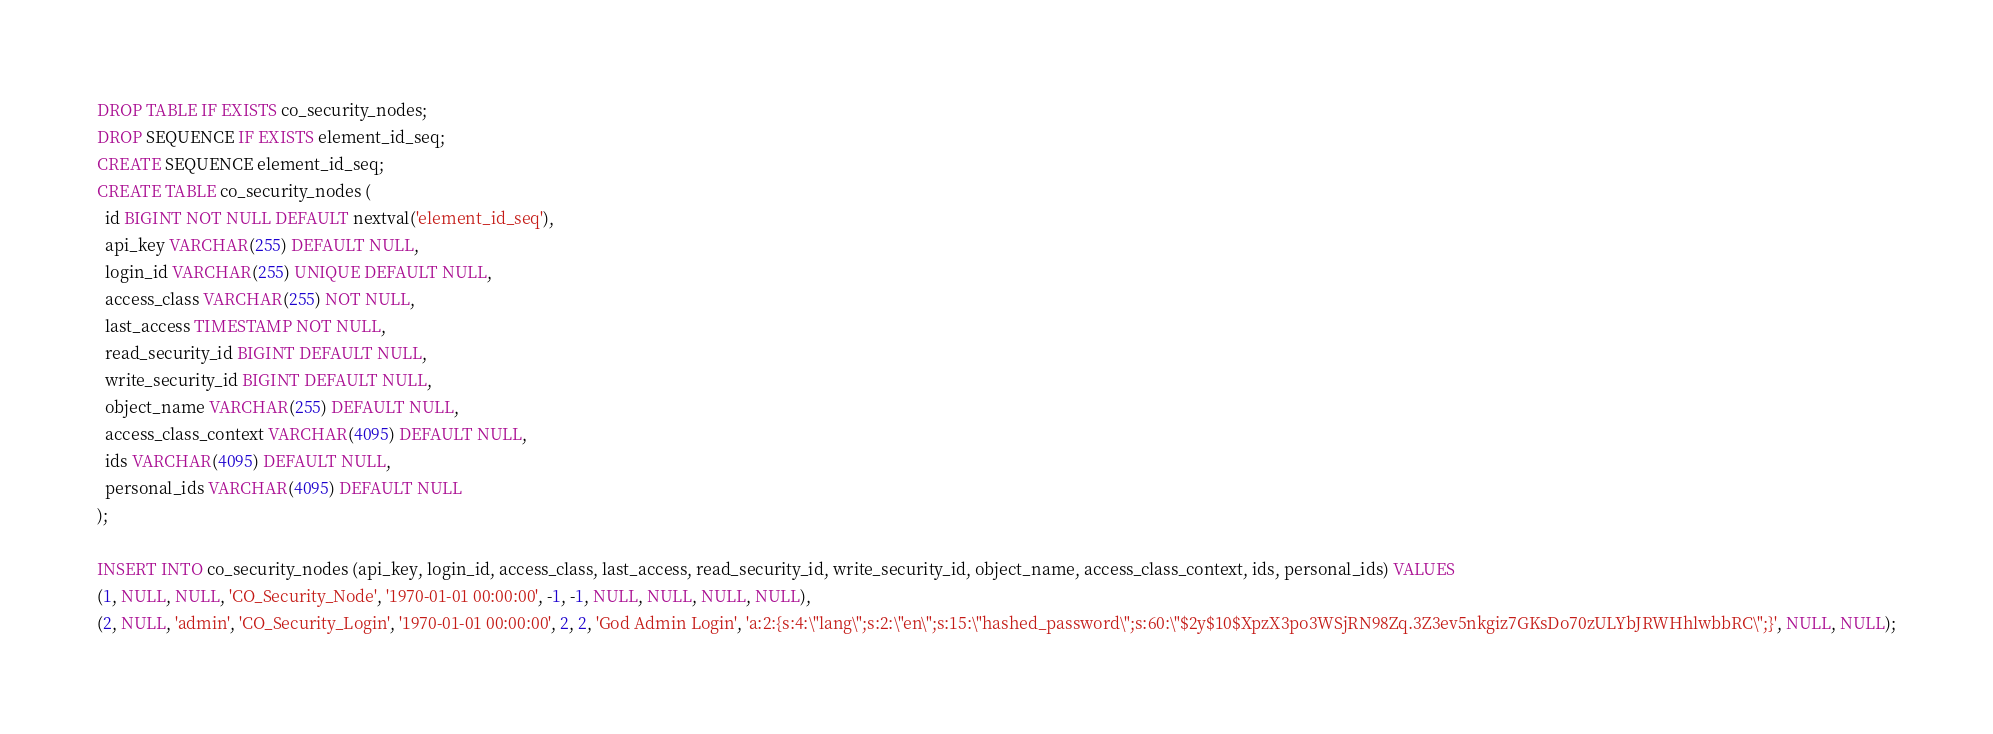Convert code to text. <code><loc_0><loc_0><loc_500><loc_500><_SQL_>DROP TABLE IF EXISTS co_security_nodes;
DROP SEQUENCE IF EXISTS element_id_seq;
CREATE SEQUENCE element_id_seq;
CREATE TABLE co_security_nodes (
  id BIGINT NOT NULL DEFAULT nextval('element_id_seq'),
  api_key VARCHAR(255) DEFAULT NULL,
  login_id VARCHAR(255) UNIQUE DEFAULT NULL,
  access_class VARCHAR(255) NOT NULL,
  last_access TIMESTAMP NOT NULL,
  read_security_id BIGINT DEFAULT NULL,
  write_security_id BIGINT DEFAULT NULL,
  object_name VARCHAR(255) DEFAULT NULL,
  access_class_context VARCHAR(4095) DEFAULT NULL,
  ids VARCHAR(4095) DEFAULT NULL,
  personal_ids VARCHAR(4095) DEFAULT NULL
);

INSERT INTO co_security_nodes (api_key, login_id, access_class, last_access, read_security_id, write_security_id, object_name, access_class_context, ids, personal_ids) VALUES
(1, NULL, NULL, 'CO_Security_Node', '1970-01-01 00:00:00', -1, -1, NULL, NULL, NULL, NULL),
(2, NULL, 'admin', 'CO_Security_Login', '1970-01-01 00:00:00', 2, 2, 'God Admin Login', 'a:2:{s:4:\"lang\";s:2:\"en\";s:15:\"hashed_password\";s:60:\"$2y$10$XpzX3po3WSjRN98Zq.3Z3ev5nkgiz7GKsDo70zULYbJRWHhlwbbRC\";}', NULL, NULL);
</code> 